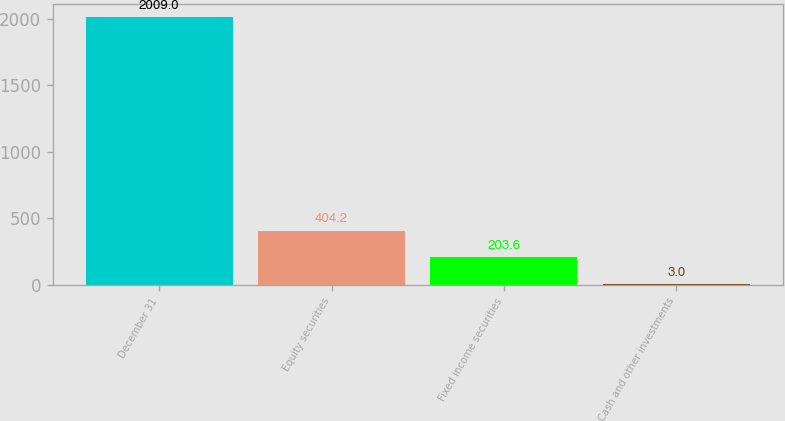Convert chart to OTSL. <chart><loc_0><loc_0><loc_500><loc_500><bar_chart><fcel>December 31<fcel>Equity securities<fcel>Fixed income securities<fcel>Cash and other investments<nl><fcel>2009<fcel>404.2<fcel>203.6<fcel>3<nl></chart> 